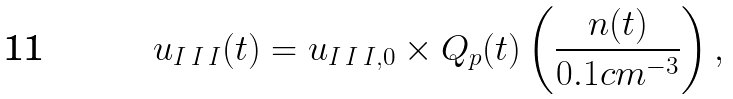Convert formula to latex. <formula><loc_0><loc_0><loc_500><loc_500>u _ { I \, I \, I } ( t ) = u _ { I \, I \, I , 0 } \times Q _ { p } ( t ) \left ( \frac { n ( t ) } { 0 . 1 c m ^ { - 3 } } \right ) ,</formula> 